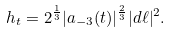<formula> <loc_0><loc_0><loc_500><loc_500>h _ { t } = 2 ^ { \frac { 1 } { 3 } } | a _ { - 3 } ( t ) | ^ { \frac { 2 } { 3 } } | d \ell | ^ { 2 } .</formula> 